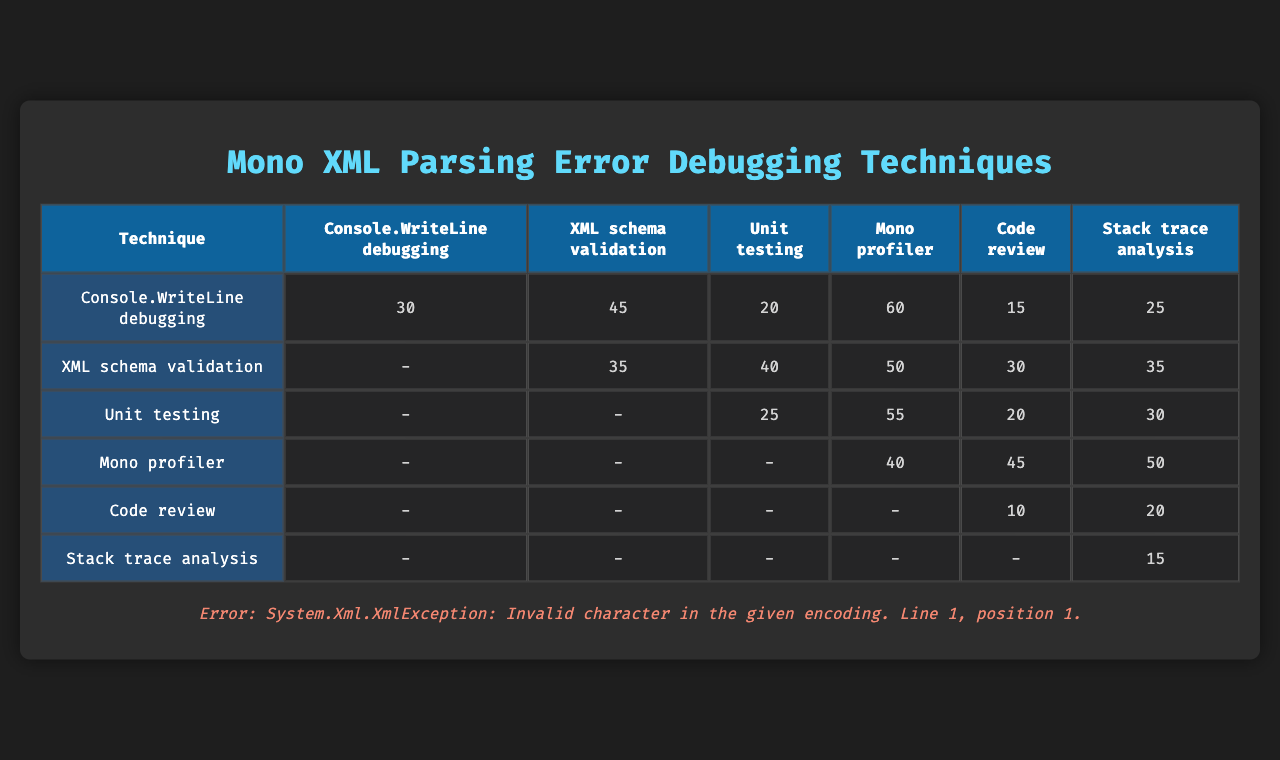What is the time spent on Console.WriteLine debugging? The table shows that the time spent on Console.WriteLine debugging is represented in the first row of the timings as 30, 45, 20, 60, 15, and 25 minutes.
Answer: 30, 45, 20, 60, 15, 25 Which debugging technique had the maximum average time spent? To find the technique with the maximum average time, I need to calculate the average for each debugging technique. For Console.WriteLine: (30+45+20+60+15+25)/6 = 32.5, XML schema validation: (0+35+40+50+30+35)/6 = 37.5, Unit testing: (0+0+25+55+20+30)/6 = 20, Mono profiler: (0+0+0+40+45+50)/6 = 35, Code review: (0+0+0+0+10+20)/6 = 5, Stack trace analysis: (0+0+0+0+0+15)/6 = 2.5. The maximum average is for XML schema validation at 37.5.
Answer: XML schema validation Was there any recorded time spent on Code review? In the table, the time spent on Code review is represented in its corresponding row, and the only times recorded are 10 and 20 minutes. Since both are greater than zero, it indicates that time was spent on Code review.
Answer: Yes What technique has the lowest time spent overall? The technique with the lowest time spent overall is Code review, with times of 0, 0, 0, 0, 10, and 20 minutes. The highest recorded time is 20 minutes in that row.
Answer: Code review How much longer was the time spent on Mono profiler compared to Unit testing on average? The average time for Mono profiler is (0+0+0+40+45+50)/6 = 35, and for Unit testing is (0+0+25+55+20+30)/6 = 20. The difference is 35 - 20 = 15 minutes.
Answer: 15 minutes What is the sum of times spent on Stack trace analysis? The times spent on Stack trace analysis are (0, 0, 0, 0, 0, 15). Summing these values, we have 0 + 0 + 0 + 0 + 0 + 15 = 15 minutes.
Answer: 15 Did the Console.WriteLine debugging technique have more time spent than Stack trace analysis? For Console.WriteLine, the maximum recorded time is 60, while Stack trace analysis only has 15. Since 60 > 15, it indicates that Console.WriteLine debugging had more time spent than Stack trace analysis.
Answer: Yes If you combine the time spent on XML schema validation and Mono profiler, what is the total? Summing the maximum times of XML schema validation (50) and Mono profiler (50), calculated as 50 + 50 = 100.
Answer: 100 